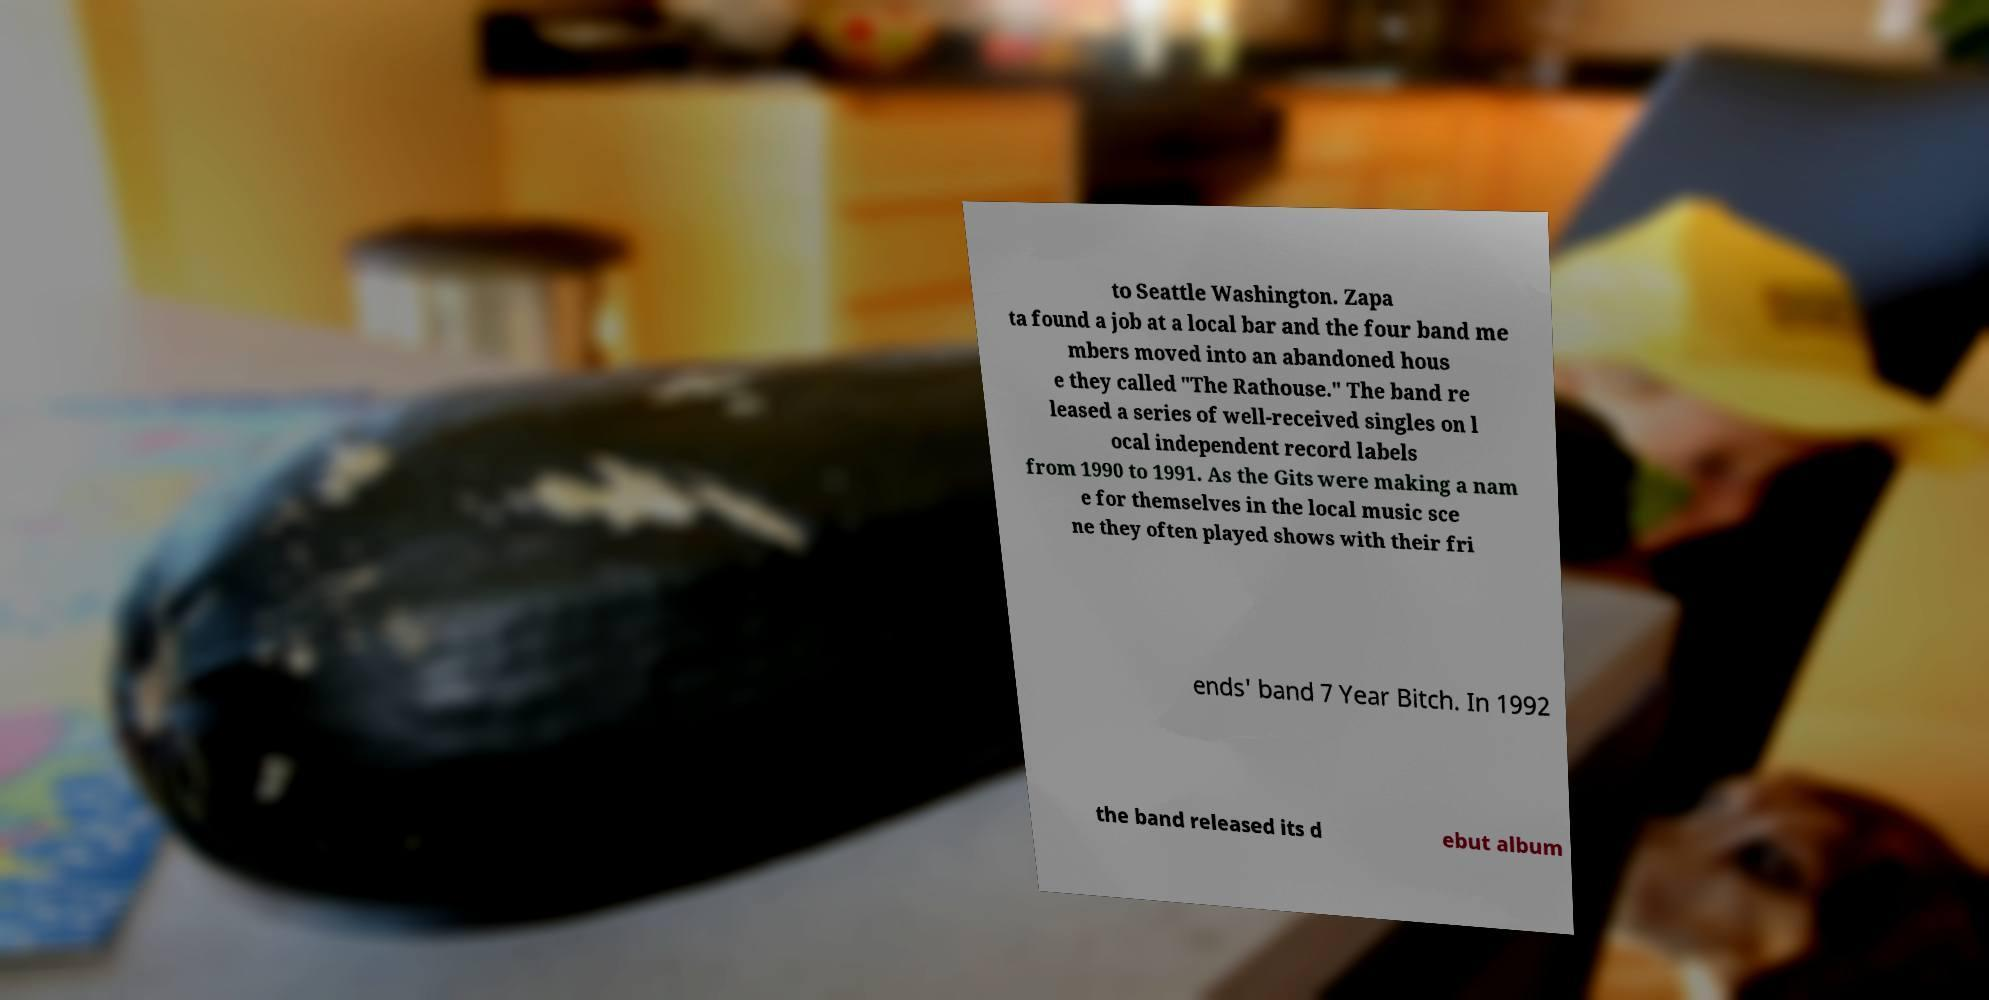There's text embedded in this image that I need extracted. Can you transcribe it verbatim? to Seattle Washington. Zapa ta found a job at a local bar and the four band me mbers moved into an abandoned hous e they called "The Rathouse." The band re leased a series of well-received singles on l ocal independent record labels from 1990 to 1991. As the Gits were making a nam e for themselves in the local music sce ne they often played shows with their fri ends' band 7 Year Bitch. In 1992 the band released its d ebut album 